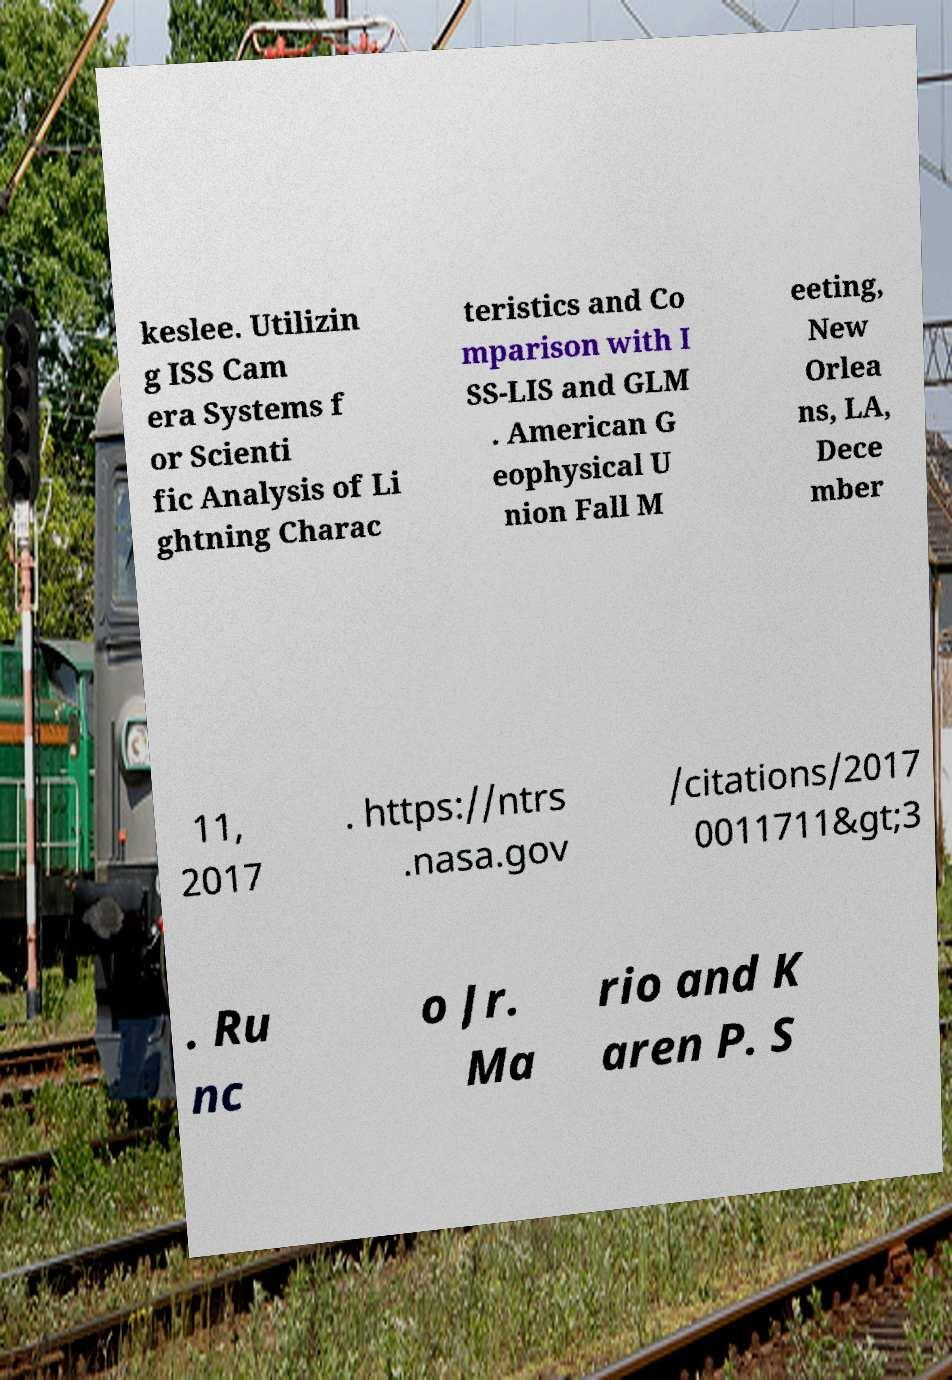Could you extract and type out the text from this image? keslee. Utilizin g ISS Cam era Systems f or Scienti fic Analysis of Li ghtning Charac teristics and Co mparison with I SS-LIS and GLM . American G eophysical U nion Fall M eeting, New Orlea ns, LA, Dece mber 11, 2017 . https://ntrs .nasa.gov /citations/2017 0011711&gt;3 . Ru nc o Jr. Ma rio and K aren P. S 